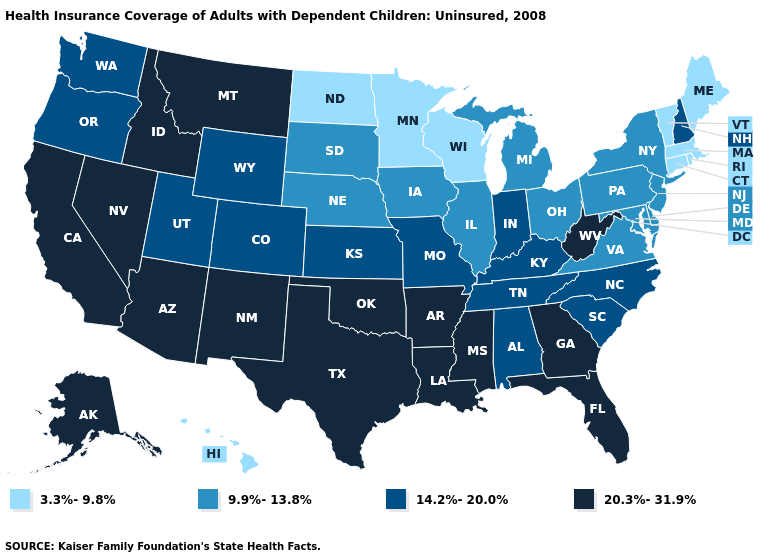Among the states that border Iowa , which have the highest value?
Keep it brief. Missouri. Name the states that have a value in the range 20.3%-31.9%?
Quick response, please. Alaska, Arizona, Arkansas, California, Florida, Georgia, Idaho, Louisiana, Mississippi, Montana, Nevada, New Mexico, Oklahoma, Texas, West Virginia. What is the highest value in the USA?
Keep it brief. 20.3%-31.9%. What is the highest value in states that border Iowa?
Keep it brief. 14.2%-20.0%. Does Illinois have a higher value than Massachusetts?
Write a very short answer. Yes. Name the states that have a value in the range 3.3%-9.8%?
Be succinct. Connecticut, Hawaii, Maine, Massachusetts, Minnesota, North Dakota, Rhode Island, Vermont, Wisconsin. Does Maryland have the lowest value in the USA?
Short answer required. No. What is the lowest value in the Northeast?
Short answer required. 3.3%-9.8%. What is the value of Florida?
Give a very brief answer. 20.3%-31.9%. Does the first symbol in the legend represent the smallest category?
Write a very short answer. Yes. Does Delaware have the lowest value in the South?
Give a very brief answer. Yes. Does Alaska have the highest value in the West?
Give a very brief answer. Yes. What is the value of Colorado?
Give a very brief answer. 14.2%-20.0%. Which states hav the highest value in the West?
Concise answer only. Alaska, Arizona, California, Idaho, Montana, Nevada, New Mexico. What is the value of Maine?
Give a very brief answer. 3.3%-9.8%. 